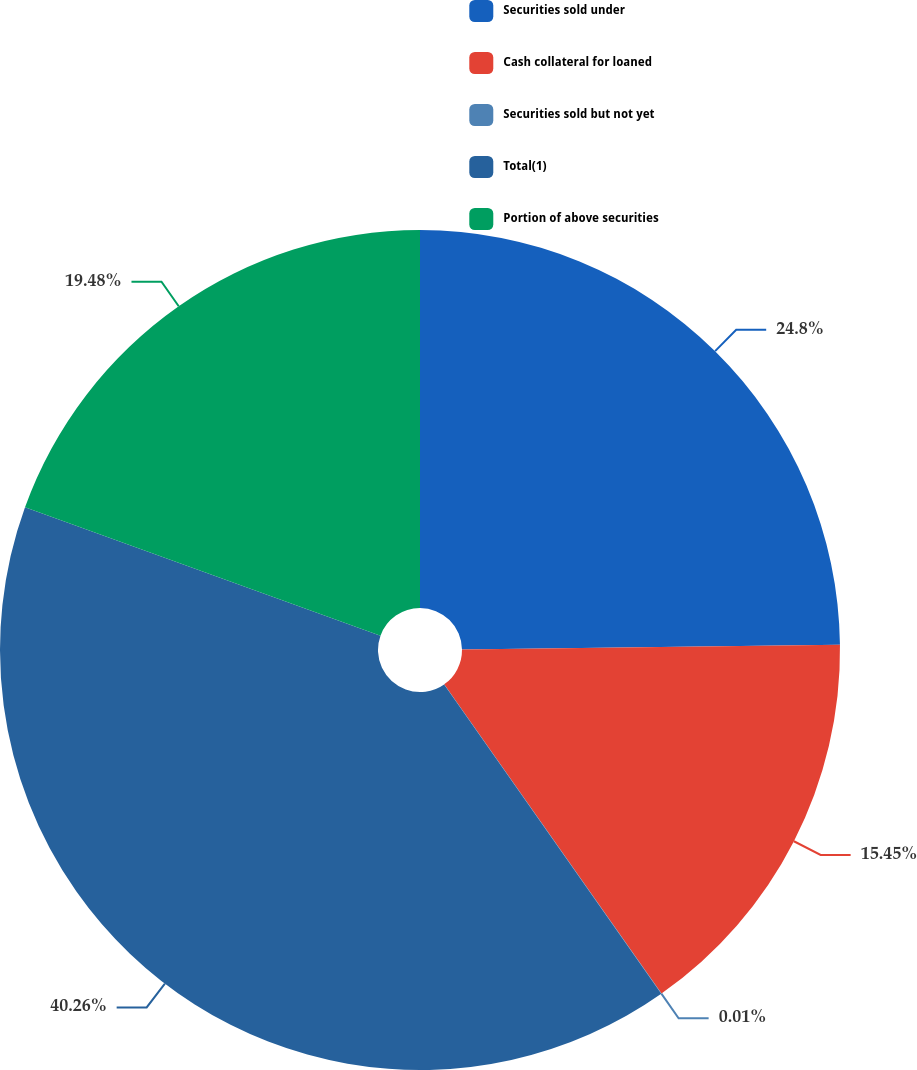<chart> <loc_0><loc_0><loc_500><loc_500><pie_chart><fcel>Securities sold under<fcel>Cash collateral for loaned<fcel>Securities sold but not yet<fcel>Total(1)<fcel>Portion of above securities<nl><fcel>24.8%<fcel>15.45%<fcel>0.01%<fcel>40.26%<fcel>19.48%<nl></chart> 